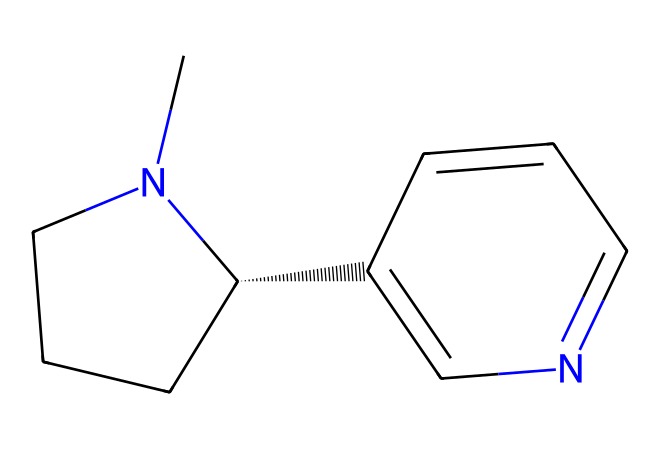What is the molecular formula of nicotine? By analyzing the provided SMILES representation, we can identify the atoms present and their counts. In this case, nicotine contains carbon (C), hydrogen (H), and nitrogen (N). The empirical formula can be derived as C10H14N2.
Answer: C10H14N2 How many nitrogen atoms are in nicotine? From the SMILES structure, it is observable that there are two nitrogen atoms clearly indicated by the presence of 'N' in the notation.
Answer: 2 What type of chemical compound is nicotine classified as? Nicotine is categorized as an alkaloid, which is a complex organic compound containing basic nitrogen atoms, derived from plants, and often having pharmacological effects.
Answer: alkaloid What is the presence of rings in the nicotine structure? The nicotine molecule contains a bicyclic structure, which is characterized by the presence of two interconnected rings (one 5-membered and one 6-membered). These rings can be inferred from the connections shown in the SMILES notation.
Answer: 2 How many carbon atoms are in the nicotine structure? The SMILES representation indicates a total of ten carbon atoms, which can be counted directly from the formula or inferred by examining the structure that includes the carbon backbone.
Answer: 10 What role do nitrogen atoms play in nicotine's pharmacological effect? The nitrogen atoms in nicotine are fundamental for its activity as they participate in forming bonds with receptors in the nervous system, affecting neurotransmitter action and leading to addiction.
Answer: pharmacological activity 